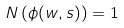<formula> <loc_0><loc_0><loc_500><loc_500>N \left ( \phi ( w , s ) \right ) = 1</formula> 